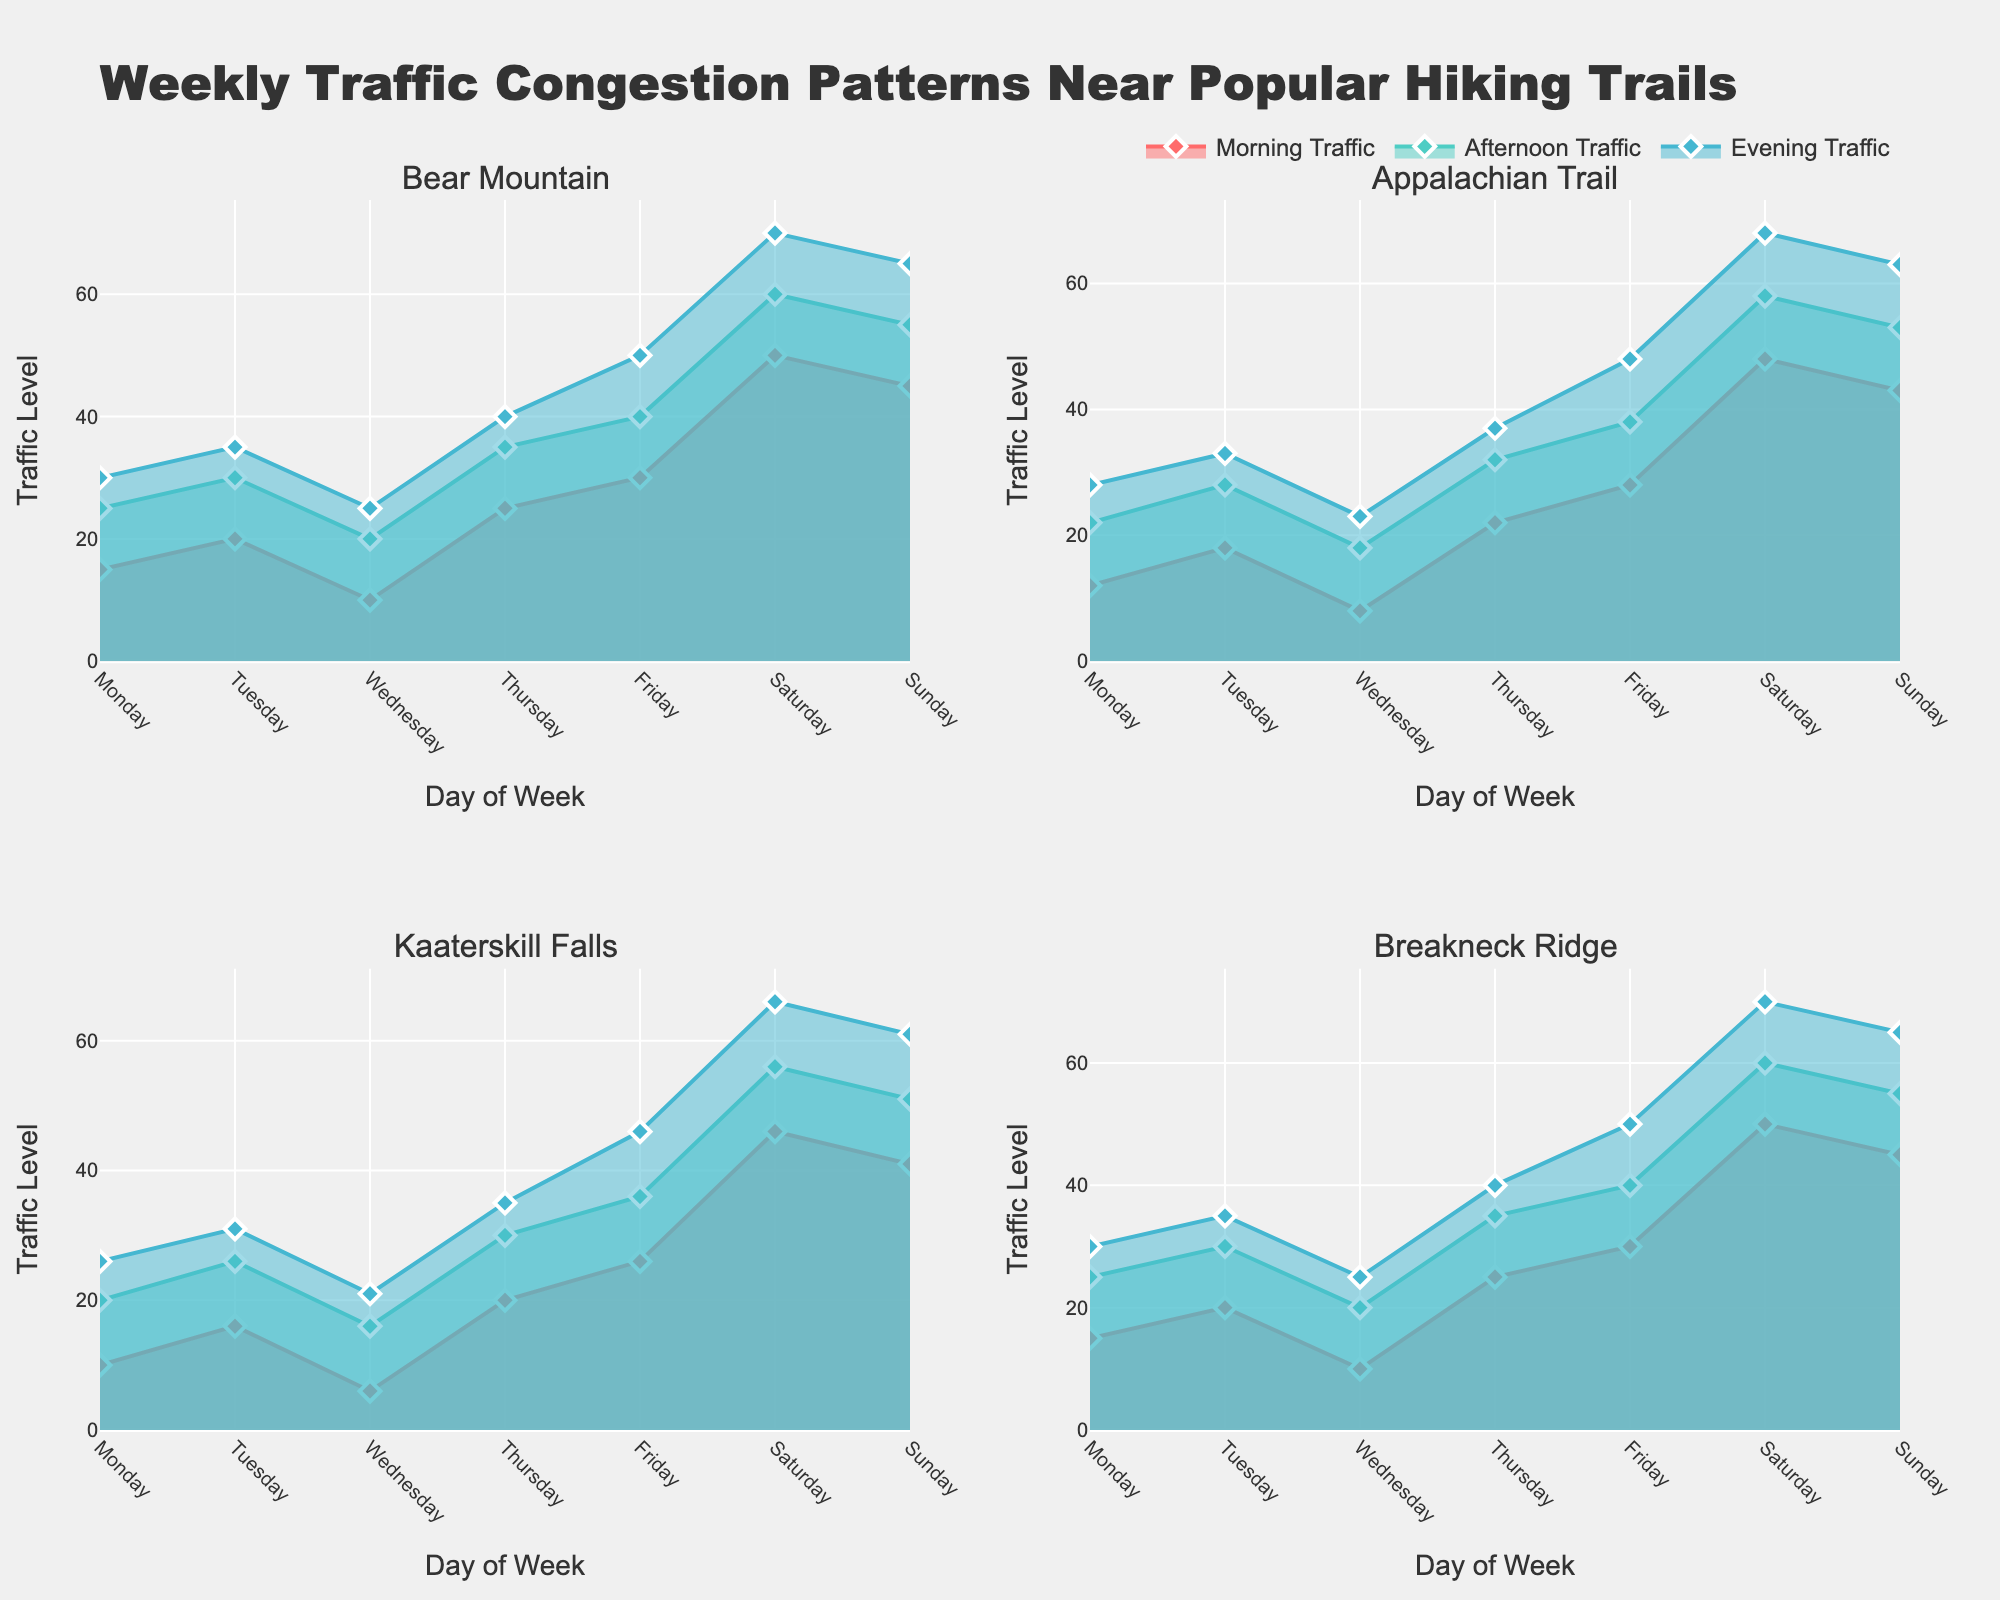Which trail experiences the highest traffic on Saturday evening? On the subplots, check the evening traffic values for each trail on Saturday and compare them. Bear Mountain and Breakneck Ridge both have the highest traffic levels at 70.
Answer: 70 (Bear Mountain and Breakneck Ridge) Which day shows the lowest morning traffic for Kaaterskill Falls? Look at the morning traffic values for Kaaterskill Falls across the days of the week and identify the smallest value. Wednesday has the lowest morning traffic at 6.
Answer: Wednesday Compare the afternoon traffic on Friday between Appalachian Trail and Breakneck Ridge. Which one is higher? Find the Friday afternoon traffic values for both Appalachian Trail and Breakneck Ridge in their respective subplots. Breakneck Ridge shows 40, while Appalachian Trail shows 38. Thus, Breakneck Ridge is higher.
Answer: Breakneck Ridge Calculate the average morning traffic for Bear Mountain across the week. Sum Bear Mountain's morning traffic values for each day (15 + 20 + 10 + 25 + 30 + 50 + 45) and divide by 7 (number of days). The sum is 195, giving an average traffic of 195 / 7 ≈ 27.86.
Answer: 27.86 What is the difference in Sunday evening traffic between Bear Mountain and Kaaterskill Falls? Identify the evening traffic values for Sunday for both trails. For Bear Mountain, it is 65; for Kaaterskill Falls, it is 61. The difference is 65 - 61.
Answer: 4 Which trail shows consistently increasing afternoon traffic from Monday to Saturday? Review each trail's subplot for the trend in afternoon traffic from Monday to Saturday. Bear Mountain and Breakneck Ridge show an increasing pattern.
Answer: Bear Mountain and Breakneck Ridge What is the total evening traffic for Appalachian Trail during the weekdays (Monday to Friday)? Sum the evening traffic values for Appalachian Trail from Monday to Friday (28 + 33 + 23 + 37 + 48). The total is 28 + 33 + 23 + 37 + 48 = 169.
Answer: 169 In which subplot do the colors for morning traffic appear as the line closest to the x-axis most often? Evaluate each subplot to see where the morning traffic line (referenced by the color code) appears closest to the x-axis. It is seen most often in the Bear Mountain subplot.
Answer: Bear Mountain On what day does Breakneck Ridge have the highest traffic across all time periods? Check each time period (morning, afternoon, evening) for the highest value in Breakneck Ridge. Saturday has the highest traffic across all time periods, with morning at 50, afternoon at 60, and evening at 70.
Answer: Saturday 